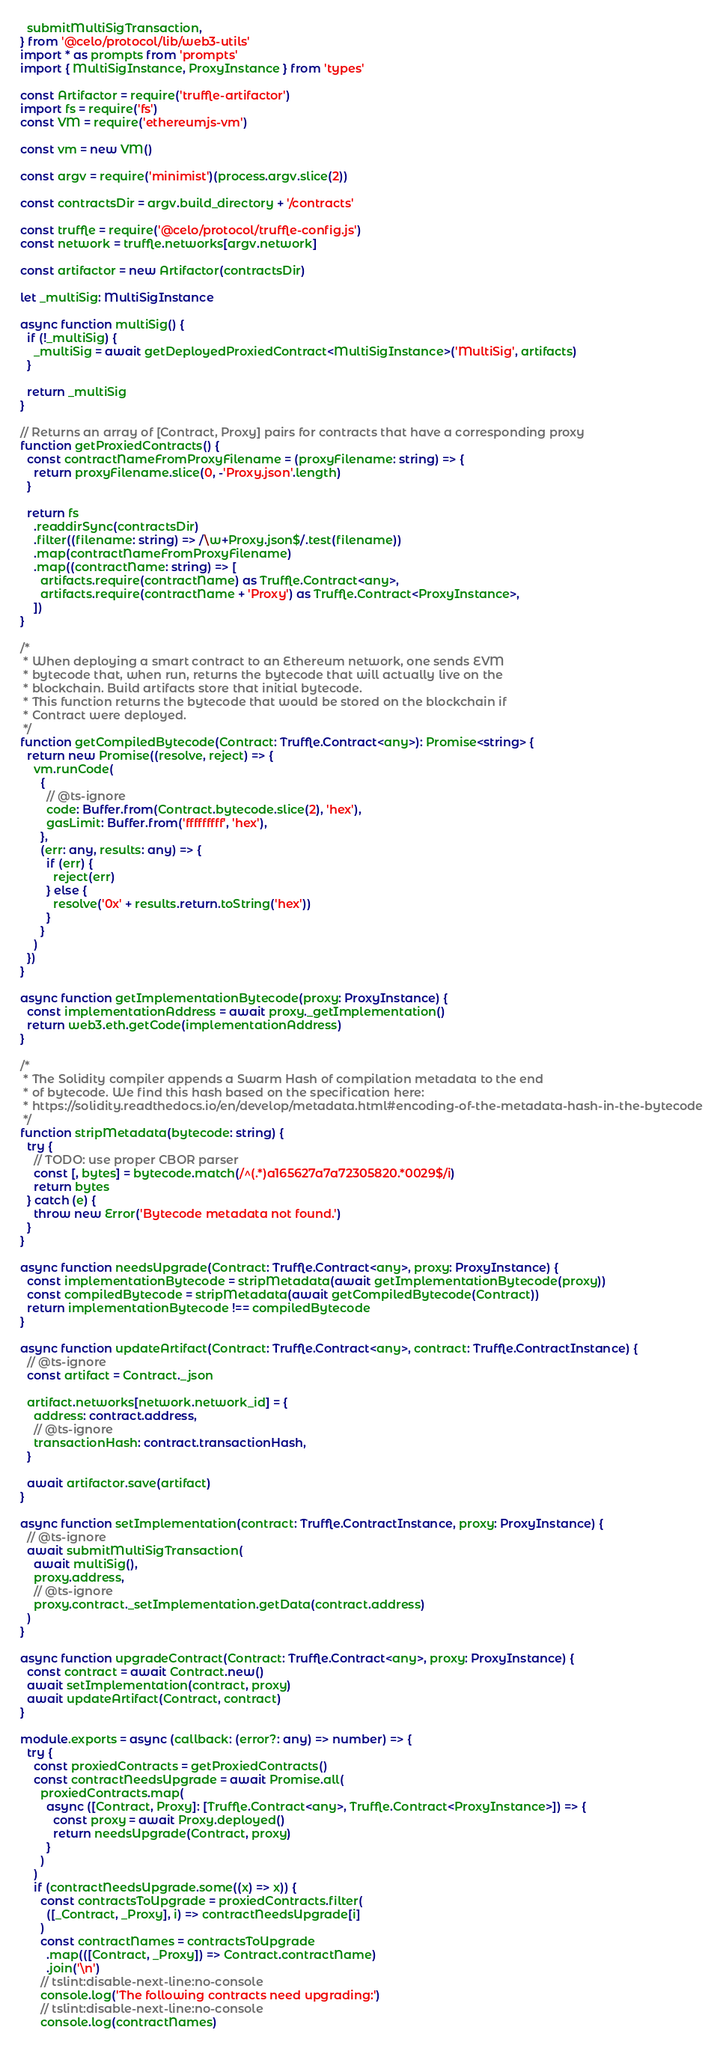<code> <loc_0><loc_0><loc_500><loc_500><_TypeScript_>  submitMultiSigTransaction,
} from '@celo/protocol/lib/web3-utils'
import * as prompts from 'prompts'
import { MultiSigInstance, ProxyInstance } from 'types'

const Artifactor = require('truffle-artifactor')
import fs = require('fs')
const VM = require('ethereumjs-vm')

const vm = new VM()

const argv = require('minimist')(process.argv.slice(2))

const contractsDir = argv.build_directory + '/contracts'

const truffle = require('@celo/protocol/truffle-config.js')
const network = truffle.networks[argv.network]

const artifactor = new Artifactor(contractsDir)

let _multiSig: MultiSigInstance

async function multiSig() {
  if (!_multiSig) {
    _multiSig = await getDeployedProxiedContract<MultiSigInstance>('MultiSig', artifacts)
  }

  return _multiSig
}

// Returns an array of [Contract, Proxy] pairs for contracts that have a corresponding proxy
function getProxiedContracts() {
  const contractNameFromProxyFilename = (proxyFilename: string) => {
    return proxyFilename.slice(0, -'Proxy.json'.length)
  }

  return fs
    .readdirSync(contractsDir)
    .filter((filename: string) => /\w+Proxy.json$/.test(filename))
    .map(contractNameFromProxyFilename)
    .map((contractName: string) => [
      artifacts.require(contractName) as Truffle.Contract<any>,
      artifacts.require(contractName + 'Proxy') as Truffle.Contract<ProxyInstance>,
    ])
}

/*
 * When deploying a smart contract to an Ethereum network, one sends EVM
 * bytecode that, when run, returns the bytecode that will actually live on the
 * blockchain. Build artifacts store that initial bytecode.
 * This function returns the bytecode that would be stored on the blockchain if
 * Contract were deployed.
 */
function getCompiledBytecode(Contract: Truffle.Contract<any>): Promise<string> {
  return new Promise((resolve, reject) => {
    vm.runCode(
      {
        // @ts-ignore
        code: Buffer.from(Contract.bytecode.slice(2), 'hex'),
        gasLimit: Buffer.from('fffffffff', 'hex'),
      },
      (err: any, results: any) => {
        if (err) {
          reject(err)
        } else {
          resolve('0x' + results.return.toString('hex'))
        }
      }
    )
  })
}

async function getImplementationBytecode(proxy: ProxyInstance) {
  const implementationAddress = await proxy._getImplementation()
  return web3.eth.getCode(implementationAddress)
}

/*
 * The Solidity compiler appends a Swarm Hash of compilation metadata to the end
 * of bytecode. We find this hash based on the specification here:
 * https://solidity.readthedocs.io/en/develop/metadata.html#encoding-of-the-metadata-hash-in-the-bytecode
 */
function stripMetadata(bytecode: string) {
  try {
    // TODO: use proper CBOR parser
    const [, bytes] = bytecode.match(/^(.*)a165627a7a72305820.*0029$/i)
    return bytes
  } catch (e) {
    throw new Error('Bytecode metadata not found.')
  }
}

async function needsUpgrade(Contract: Truffle.Contract<any>, proxy: ProxyInstance) {
  const implementationBytecode = stripMetadata(await getImplementationBytecode(proxy))
  const compiledBytecode = stripMetadata(await getCompiledBytecode(Contract))
  return implementationBytecode !== compiledBytecode
}

async function updateArtifact(Contract: Truffle.Contract<any>, contract: Truffle.ContractInstance) {
  // @ts-ignore
  const artifact = Contract._json

  artifact.networks[network.network_id] = {
    address: contract.address,
    // @ts-ignore
    transactionHash: contract.transactionHash,
  }

  await artifactor.save(artifact)
}

async function setImplementation(contract: Truffle.ContractInstance, proxy: ProxyInstance) {
  // @ts-ignore
  await submitMultiSigTransaction(
    await multiSig(),
    proxy.address,
    // @ts-ignore
    proxy.contract._setImplementation.getData(contract.address)
  )
}

async function upgradeContract(Contract: Truffle.Contract<any>, proxy: ProxyInstance) {
  const contract = await Contract.new()
  await setImplementation(contract, proxy)
  await updateArtifact(Contract, contract)
}

module.exports = async (callback: (error?: any) => number) => {
  try {
    const proxiedContracts = getProxiedContracts()
    const contractNeedsUpgrade = await Promise.all(
      proxiedContracts.map(
        async ([Contract, Proxy]: [Truffle.Contract<any>, Truffle.Contract<ProxyInstance>]) => {
          const proxy = await Proxy.deployed()
          return needsUpgrade(Contract, proxy)
        }
      )
    )
    if (contractNeedsUpgrade.some((x) => x)) {
      const contractsToUpgrade = proxiedContracts.filter(
        ([_Contract, _Proxy], i) => contractNeedsUpgrade[i]
      )
      const contractNames = contractsToUpgrade
        .map(([Contract, _Proxy]) => Contract.contractName)
        .join('\n')
      // tslint:disable-next-line:no-console
      console.log('The following contracts need upgrading:')
      // tslint:disable-next-line:no-console
      console.log(contractNames)
</code> 